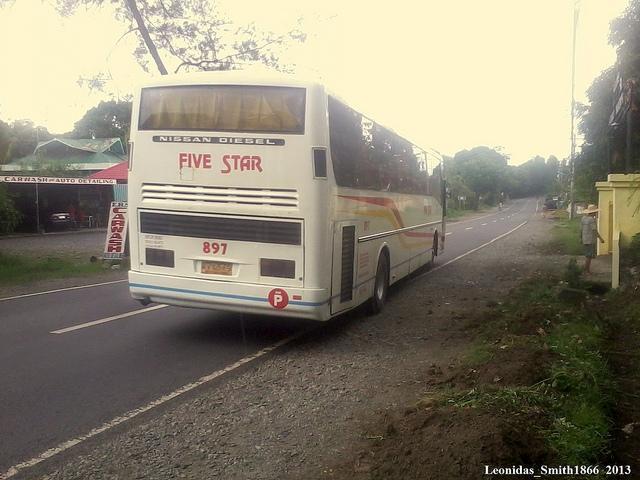How many people in the boat are wearing life jackets?
Give a very brief answer. 0. 